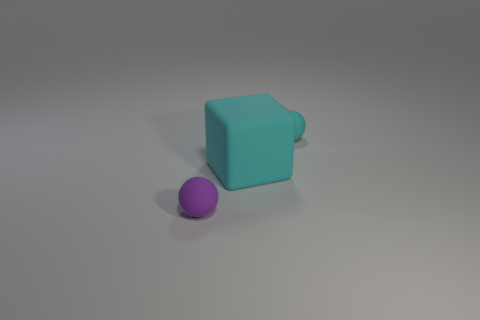Add 2 tiny balls. How many objects exist? 5 Subtract all cubes. How many objects are left? 2 Subtract all big blocks. Subtract all rubber spheres. How many objects are left? 0 Add 3 big cyan things. How many big cyan things are left? 4 Add 1 big cyan matte cubes. How many big cyan matte cubes exist? 2 Subtract 0 red balls. How many objects are left? 3 